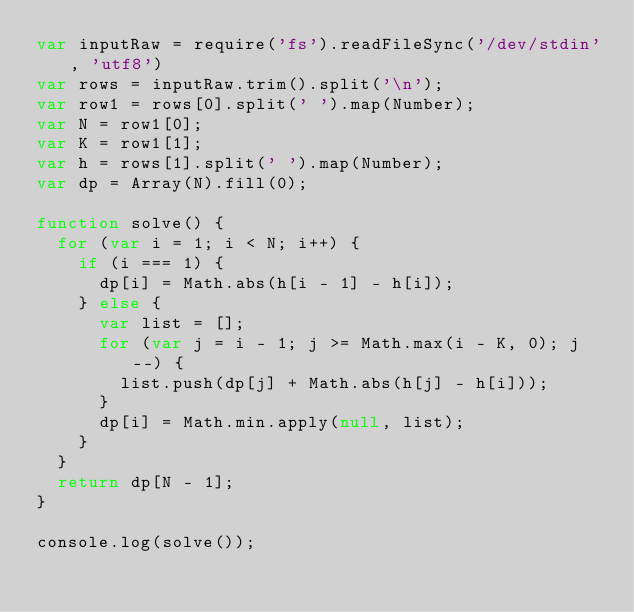<code> <loc_0><loc_0><loc_500><loc_500><_JavaScript_>var inputRaw = require('fs').readFileSync('/dev/stdin', 'utf8')
var rows = inputRaw.trim().split('\n');
var row1 = rows[0].split(' ').map(Number);
var N = row1[0];
var K = row1[1];
var h = rows[1].split(' ').map(Number);
var dp = Array(N).fill(0);

function solve() {
  for (var i = 1; i < N; i++) {
    if (i === 1) {
      dp[i] = Math.abs(h[i - 1] - h[i]);
    } else {
      var list = [];
      for (var j = i - 1; j >= Math.max(i - K, 0); j--) {
        list.push(dp[j] + Math.abs(h[j] - h[i]));
      }
      dp[i] = Math.min.apply(null, list);
    }
  }
  return dp[N - 1];
}

console.log(solve());
</code> 